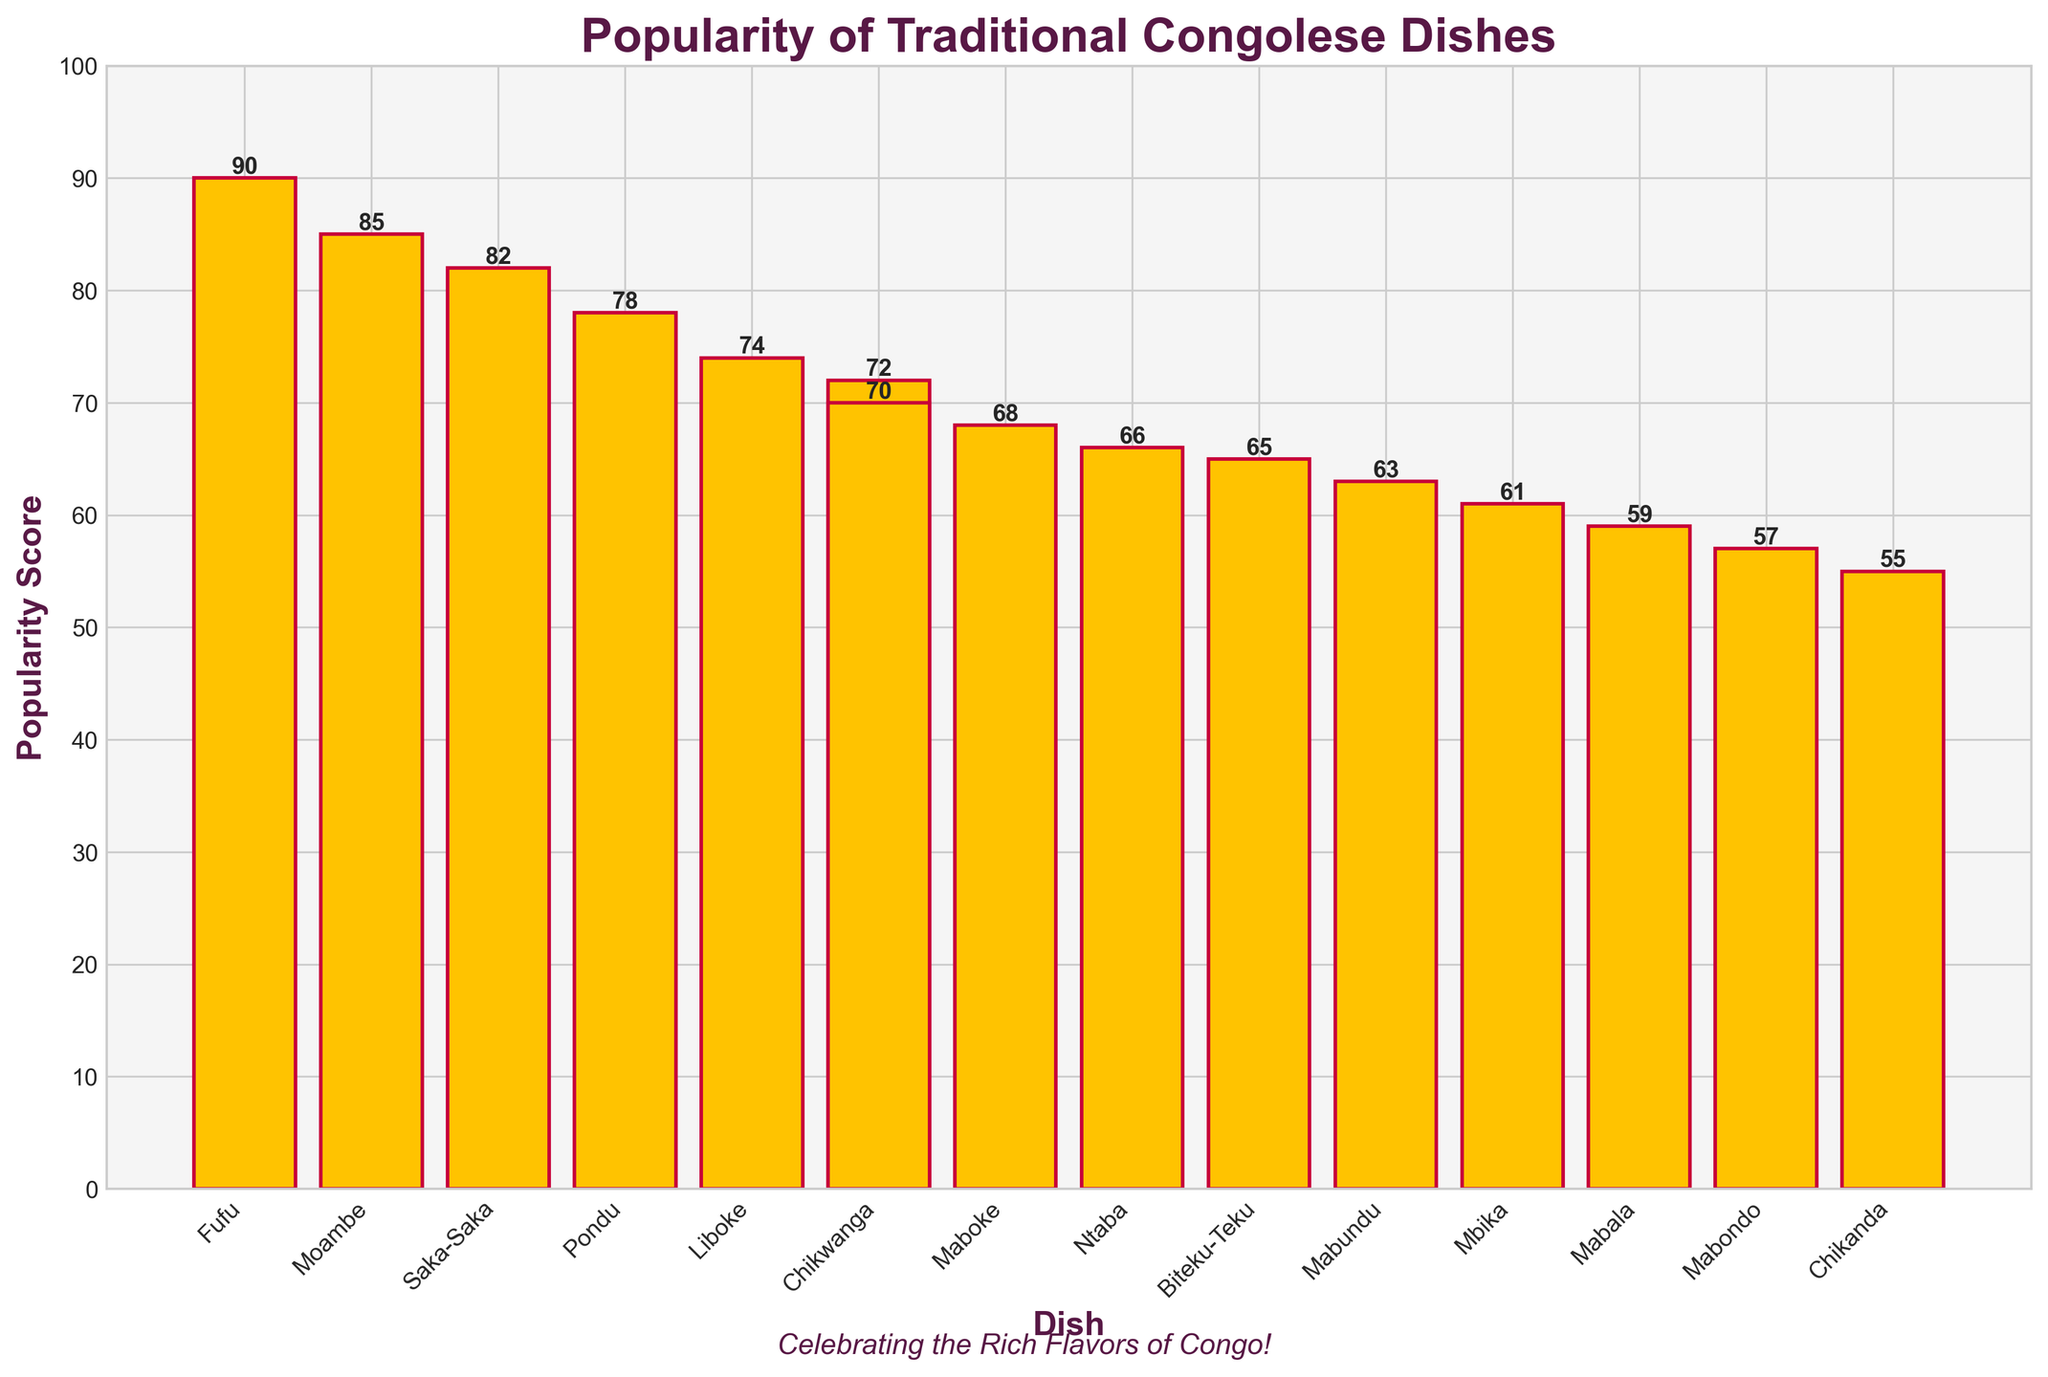Which traditional Congolese dish is the most popular? The most popular dish will have the highest bar on the plot.
Answer: Fufu Which two dishes have popularity scores close to each other? By looking at the heights of the bars, we see which bars are almost equal.
Answer: Chikwanga (72) and Pondu (78) What is the difference in popularity score between Moambe and Mabundu? Find the heights of bars for Moambe and Mabundu and calculate the difference. Moambe (85) - Mabundu (63) = 22
Answer: 22 Which dish has the least popularity score? The least popular dish will have the shortest bar in the chart.
Answer: Chikanda How many dishes have a popularity score above 70? Count the bars with heights higher than the 70 mark on the y-axis.
Answer: 6 What is the median popularity score of these dishes? List all popularity scores, sort them, and find the middle value. The sorted scores are [55, 57, 59, 61, 63, 65, 66, 68, 70, 72, 74, 78, 82, 85, 90], so the median is 68.
Answer: 68 How much more popular is Liboke compared to Ntaba? Calculate the difference in height between the bars of Liboke and Ntaba. Liboke (74) - Ntaba (66) = 8
Answer: 8 Which dish is more popular: Saka-Saka or Pondu? Compare the heights of the bars for Saka-Saka and Pondu. Saka-Saka (82) > Pondu (78)
Answer: Saka-Saka What is the average popularity score of the top 3 dishes? Find the heights of the top 3 highest bars and calculate their average. Fufu (90), Moambe (85), and Saka-Saka (82); (90 + 85 + 82) = 257 / 3 = 85.67
Answer: 85.67 What is the range of the popularity scores in the figure? Find the difference between the highest and lowest scores. Highest (90) - Lowest (55) = 35
Answer: 35 